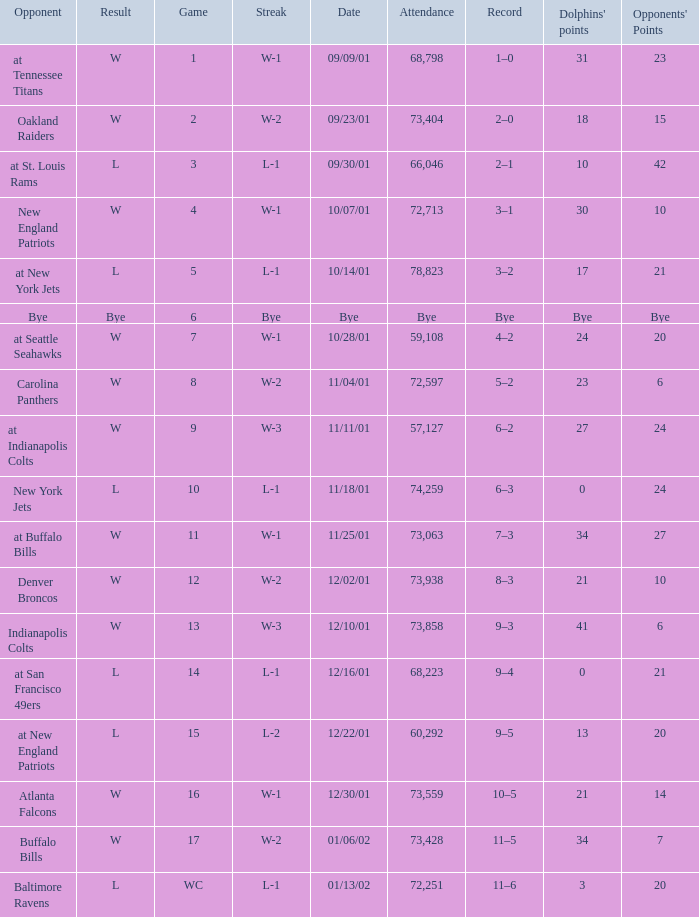How many opponents points were there on 11/11/01? 24.0. 